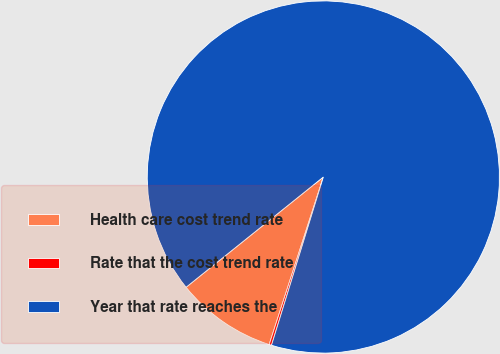<chart> <loc_0><loc_0><loc_500><loc_500><pie_chart><fcel>Health care cost trend rate<fcel>Rate that the cost trend rate<fcel>Year that rate reaches the<nl><fcel>9.25%<fcel>0.22%<fcel>90.52%<nl></chart> 